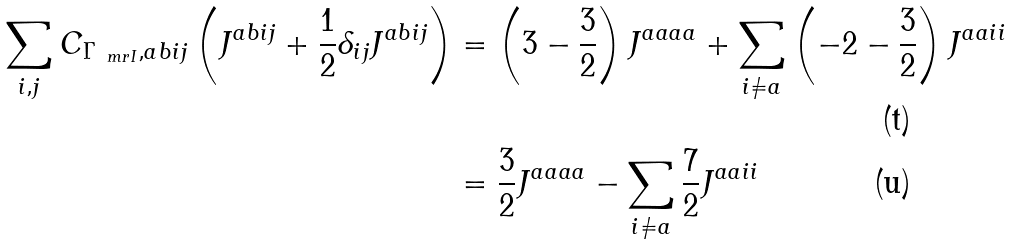Convert formula to latex. <formula><loc_0><loc_0><loc_500><loc_500>\sum _ { i , j } C _ { \Gamma _ { \ m r { I } } , a b i j } \left ( J ^ { a b i j } + \frac { 1 } { 2 } \delta _ { i j } J ^ { a b i j } \right ) & = \left ( 3 - \frac { 3 } { 2 } \right ) J ^ { a a a a } + \sum _ { i \ne a } \left ( - 2 - \frac { 3 } { 2 } \right ) J ^ { a a i i } \\ & = \frac { 3 } { 2 } J ^ { a a a a } - \sum _ { i \ne a } \frac { 7 } { 2 } J ^ { a a i i }</formula> 